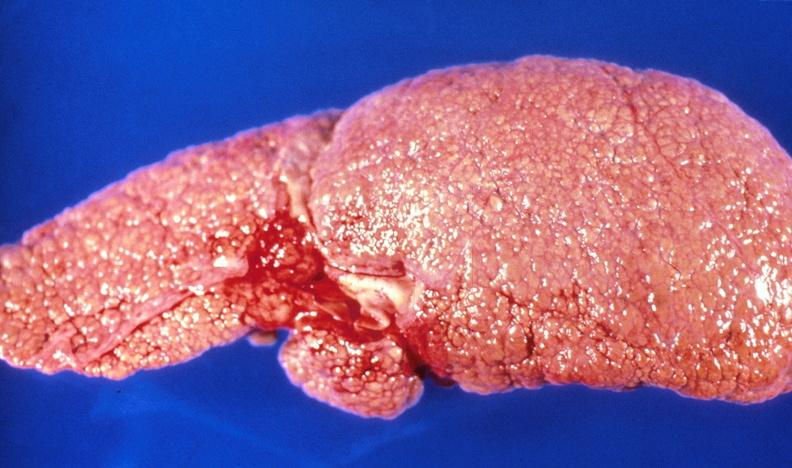s hepatobiliary present?
Answer the question using a single word or phrase. Yes 